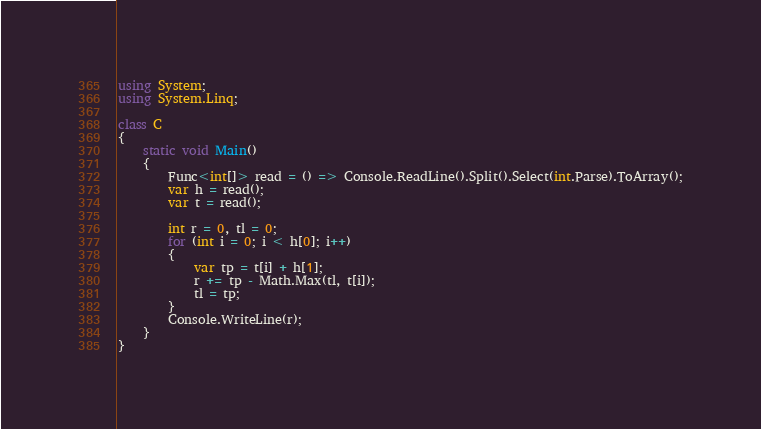Convert code to text. <code><loc_0><loc_0><loc_500><loc_500><_C#_>using System;
using System.Linq;

class C
{
	static void Main()
	{
		Func<int[]> read = () => Console.ReadLine().Split().Select(int.Parse).ToArray();
		var h = read();
		var t = read();

		int r = 0, tl = 0;
		for (int i = 0; i < h[0]; i++)
		{
			var tp = t[i] + h[1];
			r += tp - Math.Max(tl, t[i]);
			tl = tp;
		}
		Console.WriteLine(r);
	}
}
</code> 